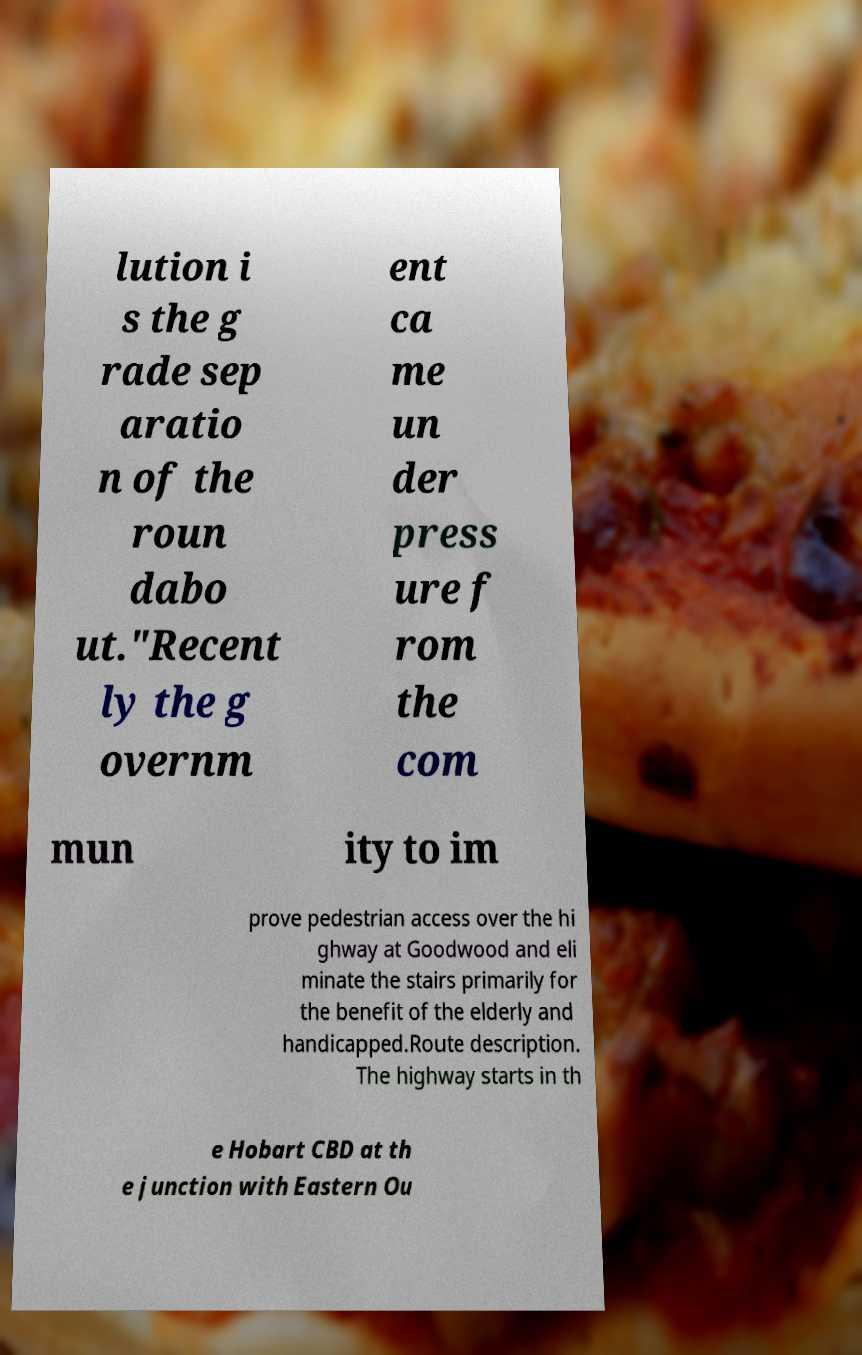I need the written content from this picture converted into text. Can you do that? lution i s the g rade sep aratio n of the roun dabo ut."Recent ly the g overnm ent ca me un der press ure f rom the com mun ity to im prove pedestrian access over the hi ghway at Goodwood and eli minate the stairs primarily for the benefit of the elderly and handicapped.Route description. The highway starts in th e Hobart CBD at th e junction with Eastern Ou 